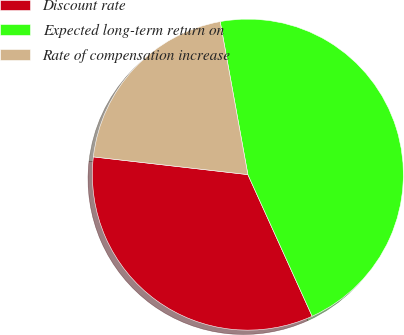<chart> <loc_0><loc_0><loc_500><loc_500><pie_chart><fcel>Discount rate<fcel>Expected long-term return on<fcel>Rate of compensation increase<nl><fcel>33.6%<fcel>46.07%<fcel>20.33%<nl></chart> 